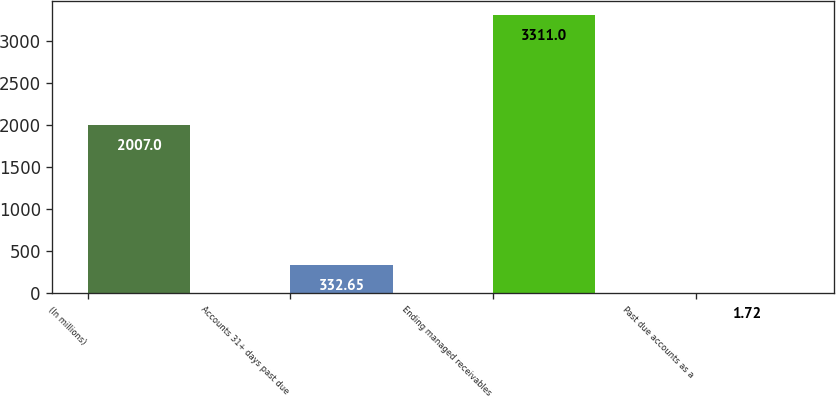<chart> <loc_0><loc_0><loc_500><loc_500><bar_chart><fcel>(In millions)<fcel>Accounts 31+ days past due<fcel>Ending managed receivables<fcel>Past due accounts as a<nl><fcel>2007<fcel>332.65<fcel>3311<fcel>1.72<nl></chart> 